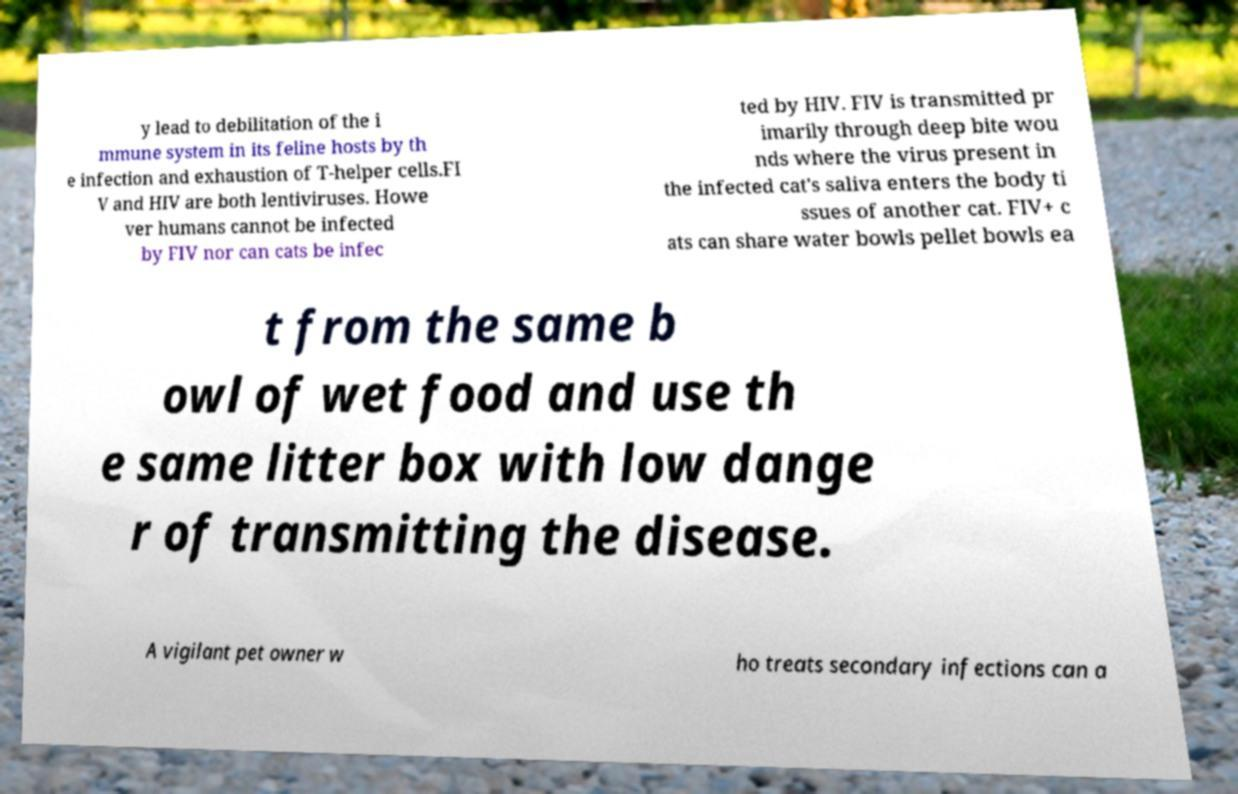For documentation purposes, I need the text within this image transcribed. Could you provide that? y lead to debilitation of the i mmune system in its feline hosts by th e infection and exhaustion of T-helper cells.FI V and HIV are both lentiviruses. Howe ver humans cannot be infected by FIV nor can cats be infec ted by HIV. FIV is transmitted pr imarily through deep bite wou nds where the virus present in the infected cat's saliva enters the body ti ssues of another cat. FIV+ c ats can share water bowls pellet bowls ea t from the same b owl of wet food and use th e same litter box with low dange r of transmitting the disease. A vigilant pet owner w ho treats secondary infections can a 